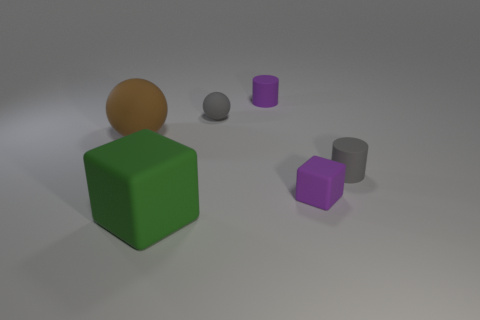Add 3 tiny matte things. How many objects exist? 9 Subtract all balls. How many objects are left? 4 Add 1 red rubber cylinders. How many red rubber cylinders exist? 1 Subtract 0 purple balls. How many objects are left? 6 Subtract all large brown balls. Subtract all small purple cylinders. How many objects are left? 4 Add 4 big green cubes. How many big green cubes are left? 5 